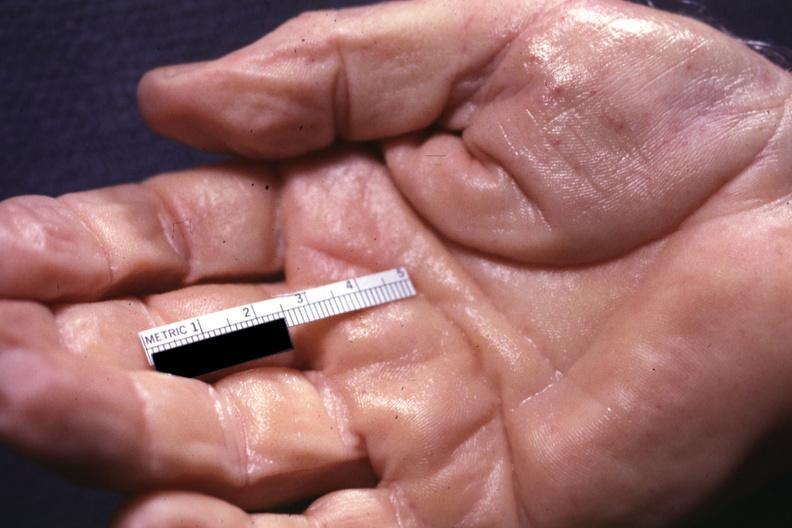does atrophy show well shown simian crease?
Answer the question using a single word or phrase. Yes 